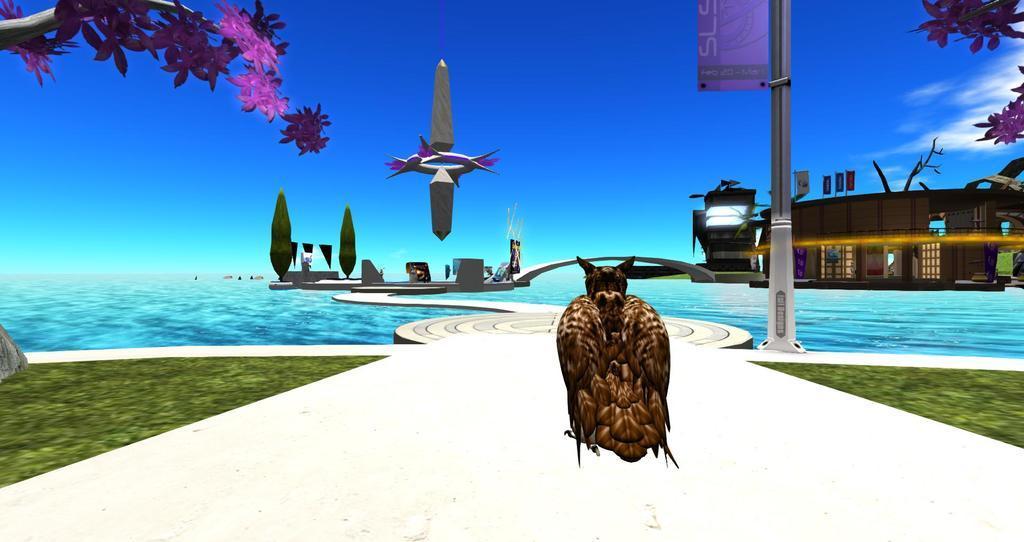Describe this image in one or two sentences. This is an animated image, in this image there is the sky truncated towards the top of the image, there are clouds in the sky, there is a building truncated towards the right of the image, there is a tree truncated towards the right of the image, there is a tree truncated towards the top of the image, there is an object flying in the air, there is a pole truncated towards the top of the image, there is a board truncated towards the top of the image, there is text on the board, there are trees, there are objects on the ground, there is water truncated, there is a bird on the ground, there is grass truncated towards the left of the image, there is grass truncated towards the right of the image, there are flowers on the tree, at the bottom of the image there is the ground truncated. 